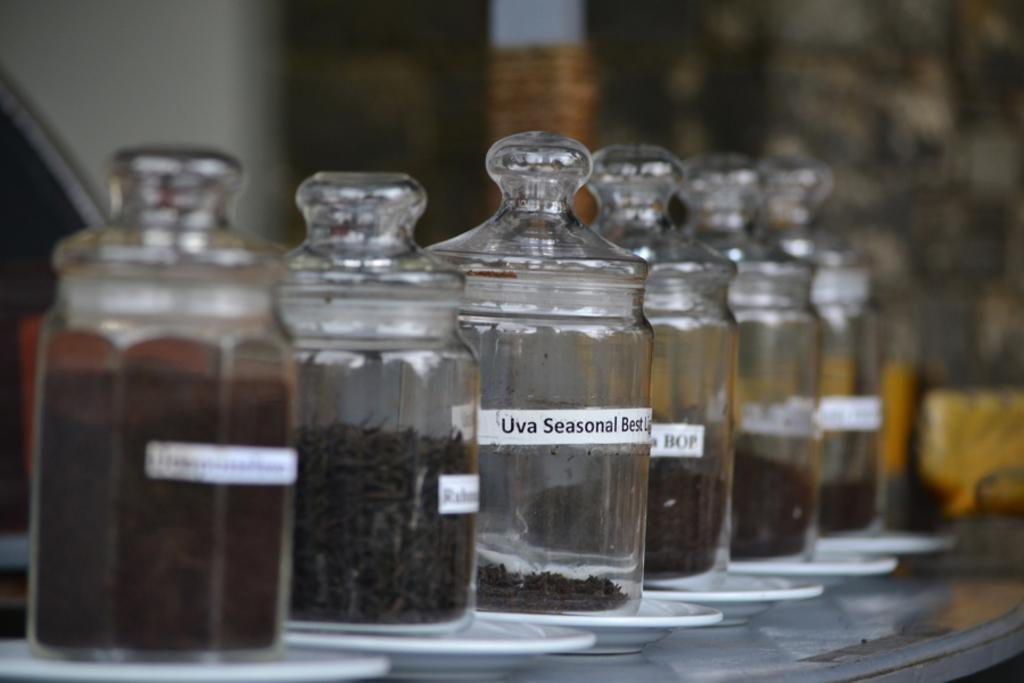Provide a one-sentence caption for the provided image. A row of glass containers with one label stating Uva Seasonal. 